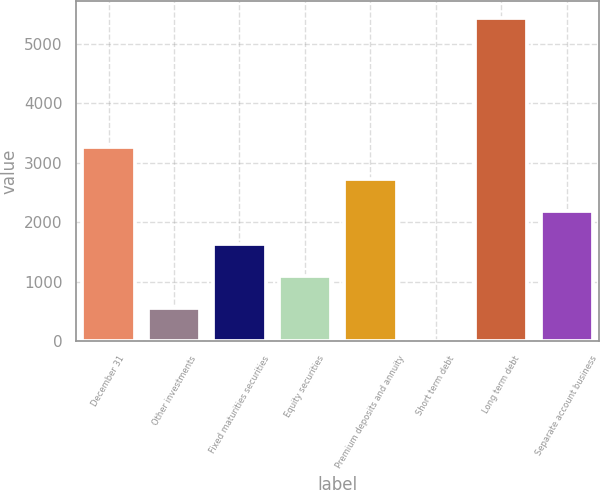<chart> <loc_0><loc_0><loc_500><loc_500><bar_chart><fcel>December 31<fcel>Other investments<fcel>Fixed maturities securities<fcel>Equity securities<fcel>Premium deposits and annuity<fcel>Short term debt<fcel>Long term debt<fcel>Separate account business<nl><fcel>3265<fcel>547.5<fcel>1634.5<fcel>1091<fcel>2721.5<fcel>4<fcel>5439<fcel>2178<nl></chart> 